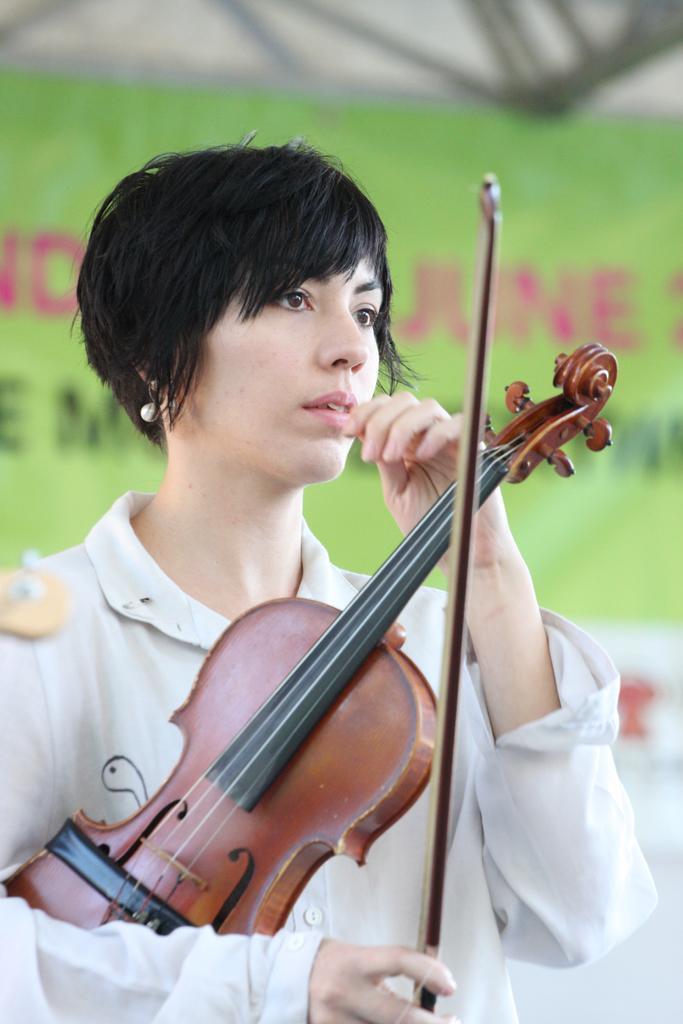Describe this image in one or two sentences. In this picture there is a woman wearing white dress is holding a violin in her hand and there is a green color banner behind her which has something written on it. 